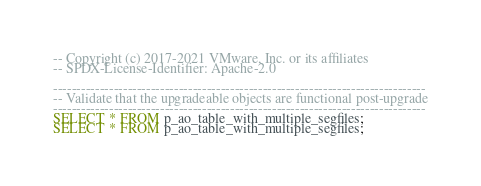Convert code to text. <code><loc_0><loc_0><loc_500><loc_500><_SQL_>-- Copyright (c) 2017-2021 VMware, Inc. or its affiliates
-- SPDX-License-Identifier: Apache-2.0

--------------------------------------------------------------------------------
-- Validate that the upgradeable objects are functional post-upgrade
--------------------------------------------------------------------------------
SELECT * FROM p_ao_table_with_multiple_segfiles;
SELECT * FROM p_ao_table_with_multiple_segfiles;
</code> 